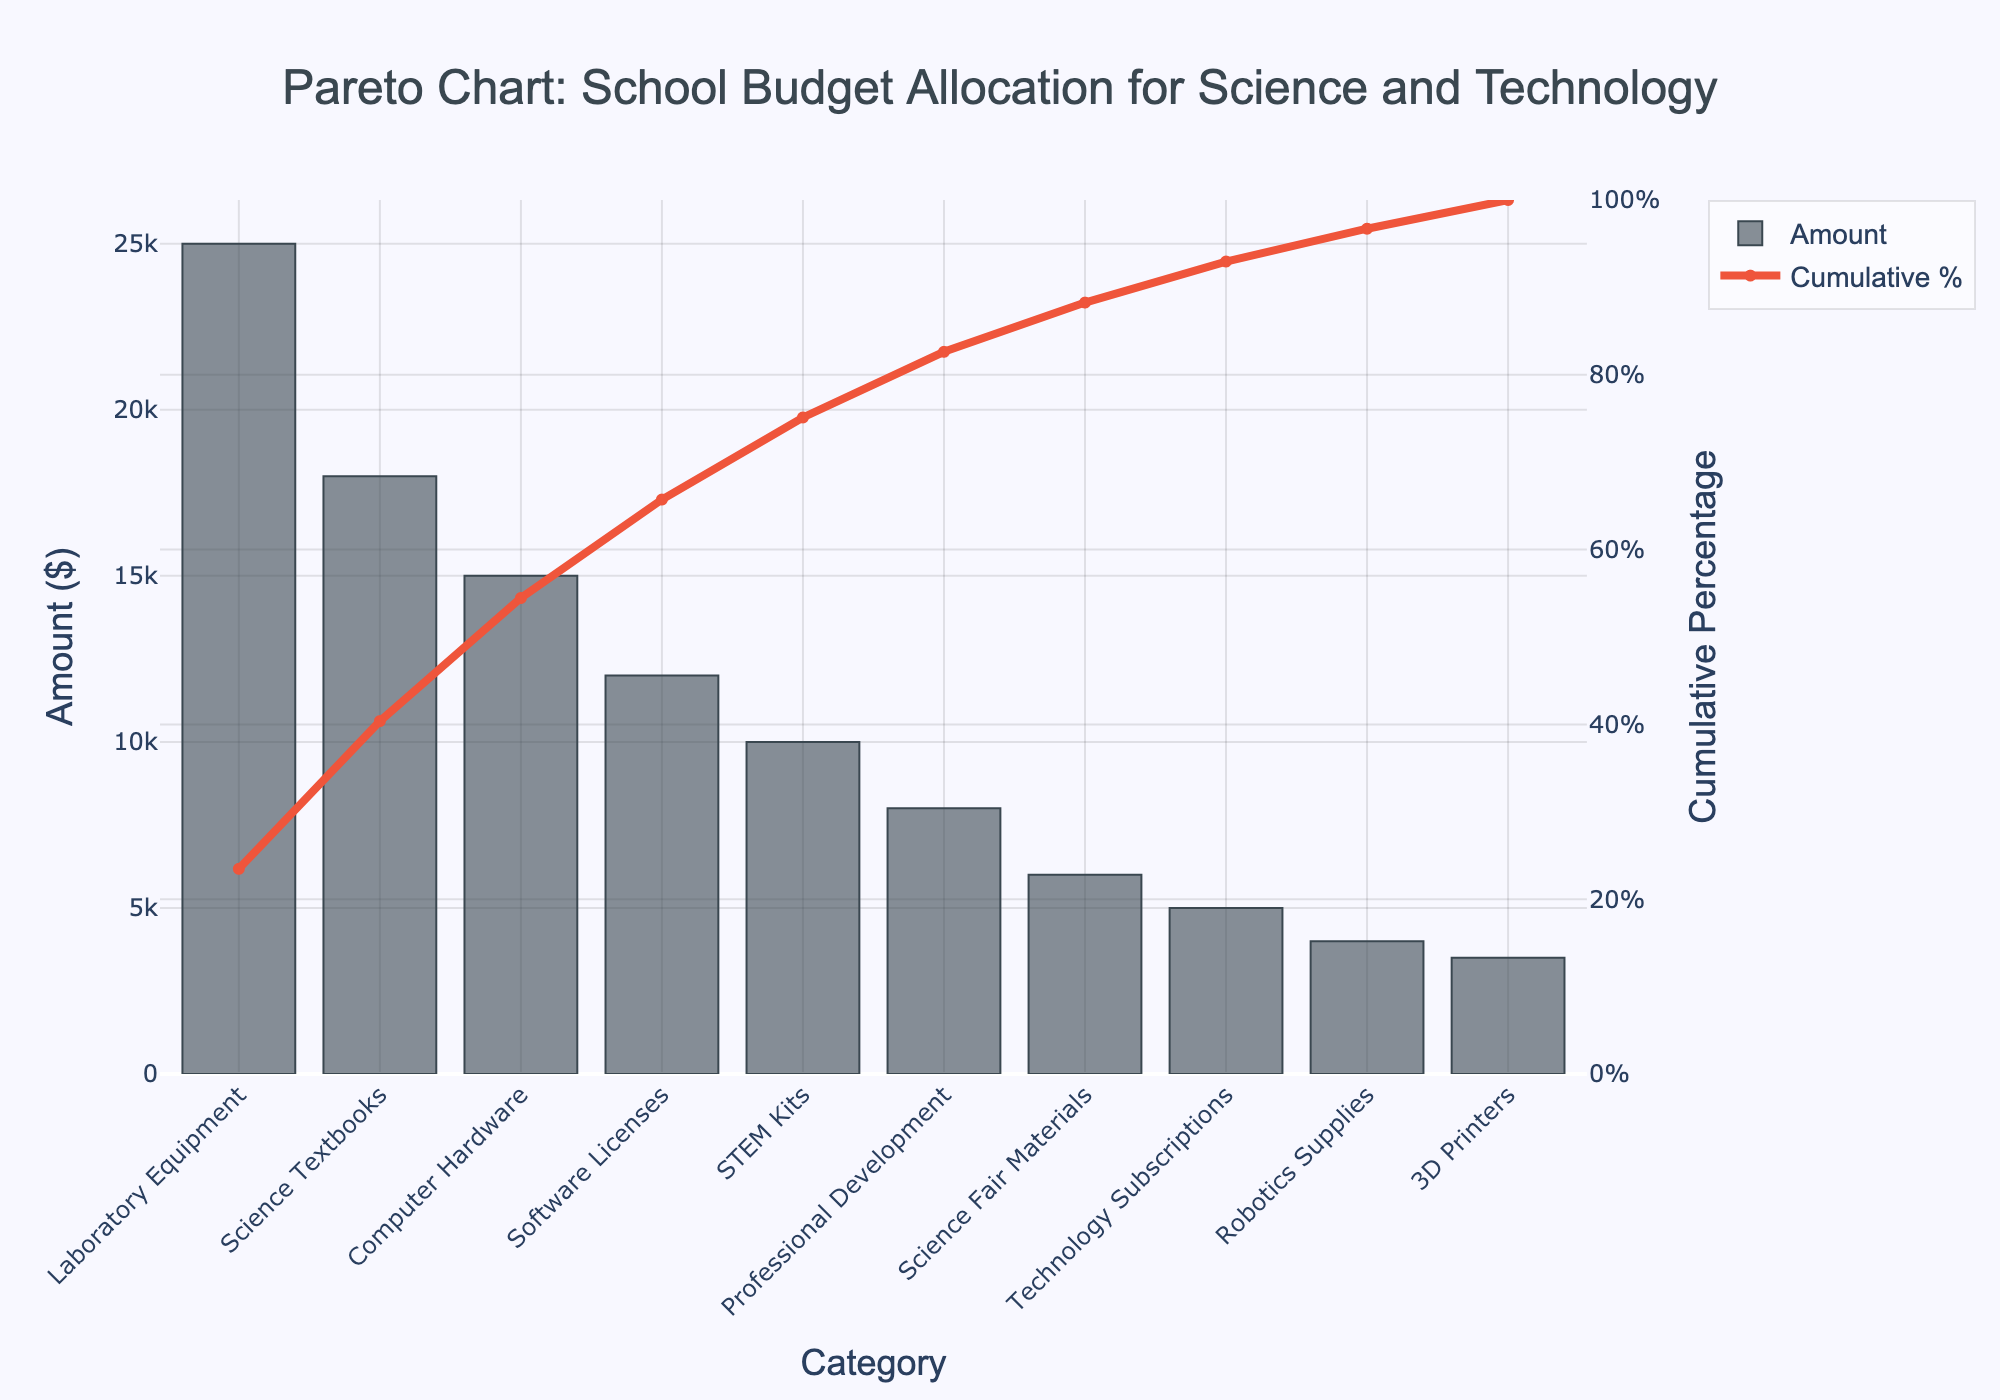What is the title of the Pareto chart? The title is located at the top of the chart, centered and in a larger font size. It provides a summary of what the chart represents.
Answer: Pareto Chart: School Budget Allocation for Science and Technology How much was allocated to Laboratory Equipment? Locate the bar representing Laboratory Equipment on the x-axis and read the corresponding amount on the y-axis. It is the highest bar.
Answer: $25,000 What are the top three spending categories by amount? Focus on the three tallest bars on the bar chart, which represent the highest amounts.
Answer: Laboratory Equipment, Science Textbooks, Computer Hardware What is the cumulative percentage for Professional Development? Find the bar for Professional Development on the x-axis and then follow the line plot (cumulative percentage) to see where it intersects.
Answer: 85% Which category has the lowest amount allocated, and how much is it? Identify the shortest bar on the bar chart, and note the category label and corresponding value.
Answer: 3D Printers, $3,500 What categories fall within the top 80% of cumulative spending? Find the point where the cumulative percentage line reaches approximately 80%, then list all categories up to this point.
Answer: Laboratory Equipment, Science Textbooks, Computer Hardware, Software Licenses, STEM Kits How do the amounts allocated to Software Licenses and STEM Kits compare? Look at the heights of the bars for Software Licenses and STEM Kits and compare their lengths on the y-axis.
Answer: Software Licenses is $12,000 and STEM Kits is $10,000, so Software Licenses is greater What is the total amount spent on Computer Hardware, Software Licenses, and Technology Subscriptions? Sum the amounts for each specified category from the chart. Computer Hardware ($15,000) + Software Licenses ($12,000) + Technology Subscriptions ($5,000).
Answer: $32,000 If the budget allocation for Science Fair Materials were to be doubled, what would be the new total spending in that category? Multiply the current amount for Science Fair Materials by 2. The current amount is $6,000.
Answer: $12,000 Which spending category contributes to the 50% mark in cumulative percentage? Find the point on the cumulative percentage line that hits 50%, then identify the corresponding category.
Answer: Science Textbooks 